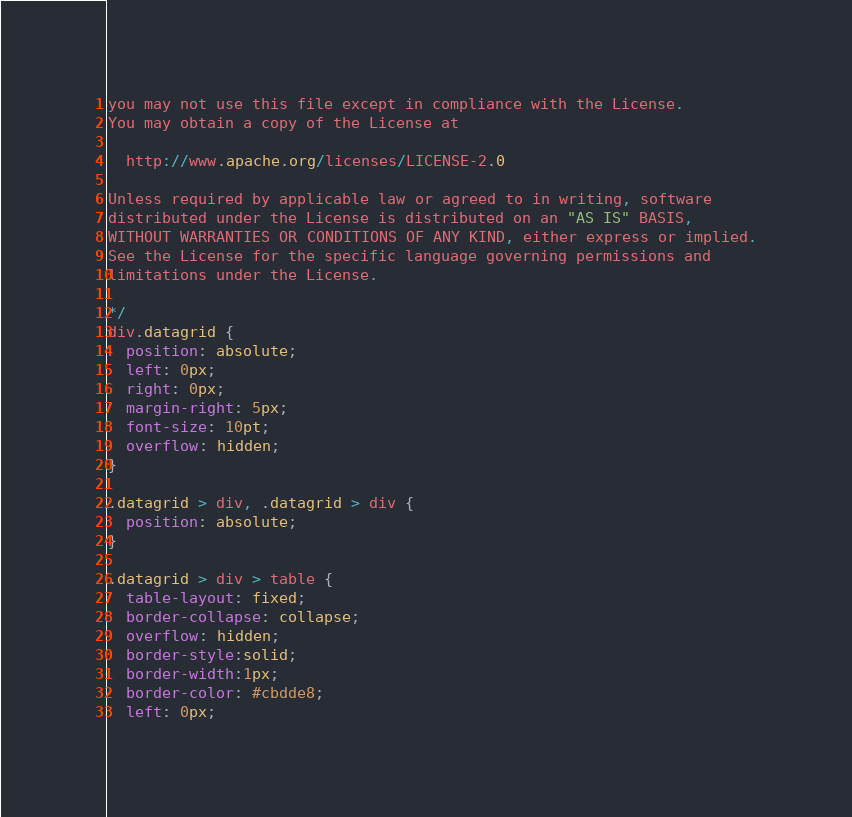Convert code to text. <code><loc_0><loc_0><loc_500><loc_500><_CSS_>you may not use this file except in compliance with the License.
You may obtain a copy of the License at

  http://www.apache.org/licenses/LICENSE-2.0

Unless required by applicable law or agreed to in writing, software
distributed under the License is distributed on an "AS IS" BASIS,
WITHOUT WARRANTIES OR CONDITIONS OF ANY KIND, either express or implied.
See the License for the specific language governing permissions and
limitations under the License.

*/
div.datagrid {
  position: absolute;
  left: 0px;
  right: 0px;
  margin-right: 5px;
  font-size: 10pt;
  overflow: hidden;
}

.datagrid > div, .datagrid > div {
  position: absolute;
}

.datagrid > div > table {
  table-layout: fixed;
  border-collapse: collapse;
  overflow: hidden;
  border-style:solid;
  border-width:1px;
  border-color: #cbdde8;
  left: 0px;</code> 